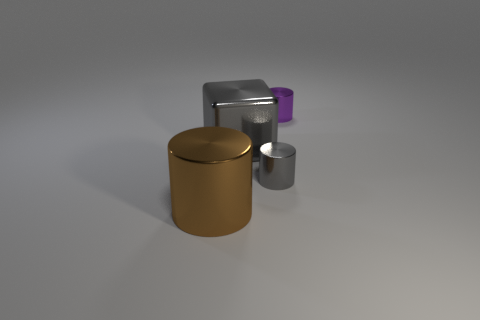Subtract all brown cylinders. How many cylinders are left? 2 Add 4 big gray shiny things. How many objects exist? 8 Subtract 2 cylinders. How many cylinders are left? 1 Subtract 1 brown cylinders. How many objects are left? 3 Subtract all blocks. How many objects are left? 3 Subtract all brown cubes. Subtract all brown cylinders. How many cubes are left? 1 Subtract all cyan spheres. How many gray cylinders are left? 1 Subtract all purple things. Subtract all big purple rubber cylinders. How many objects are left? 3 Add 1 metal cylinders. How many metal cylinders are left? 4 Add 4 large brown objects. How many large brown objects exist? 5 